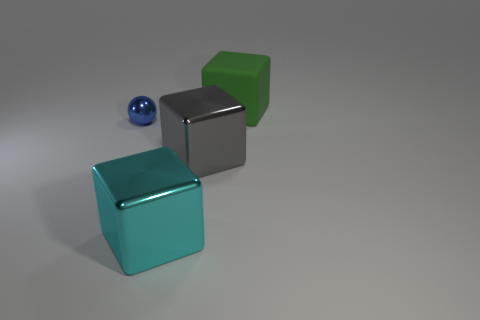Subtract all cyan blocks. Subtract all purple balls. How many blocks are left? 2 Add 2 tiny gray metallic cubes. How many objects exist? 6 Subtract all spheres. How many objects are left? 3 Add 4 spheres. How many spheres exist? 5 Subtract 0 yellow cylinders. How many objects are left? 4 Subtract all big cyan things. Subtract all blue metallic spheres. How many objects are left? 2 Add 3 large gray blocks. How many large gray blocks are left? 4 